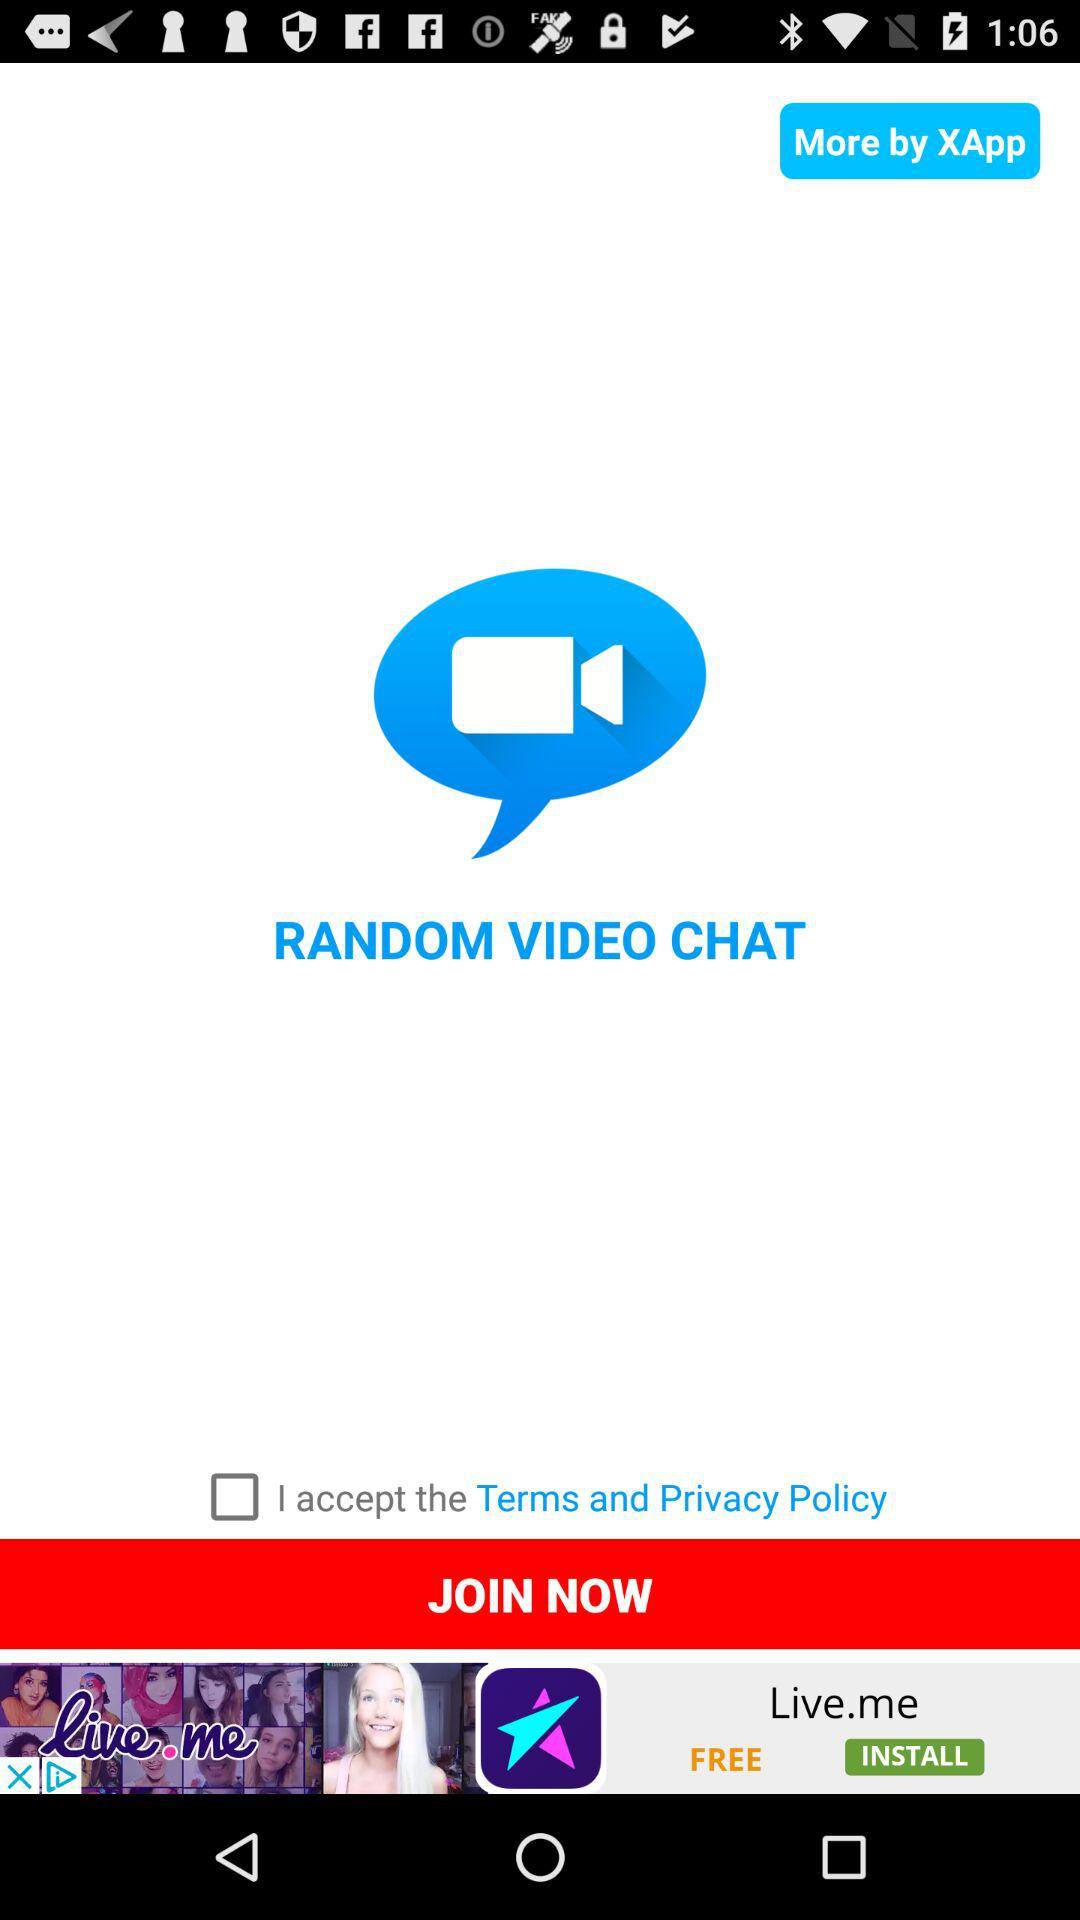What is the status of the option that includes acceptance to the "Terms" and Privacy Policy"? The status is "off". 